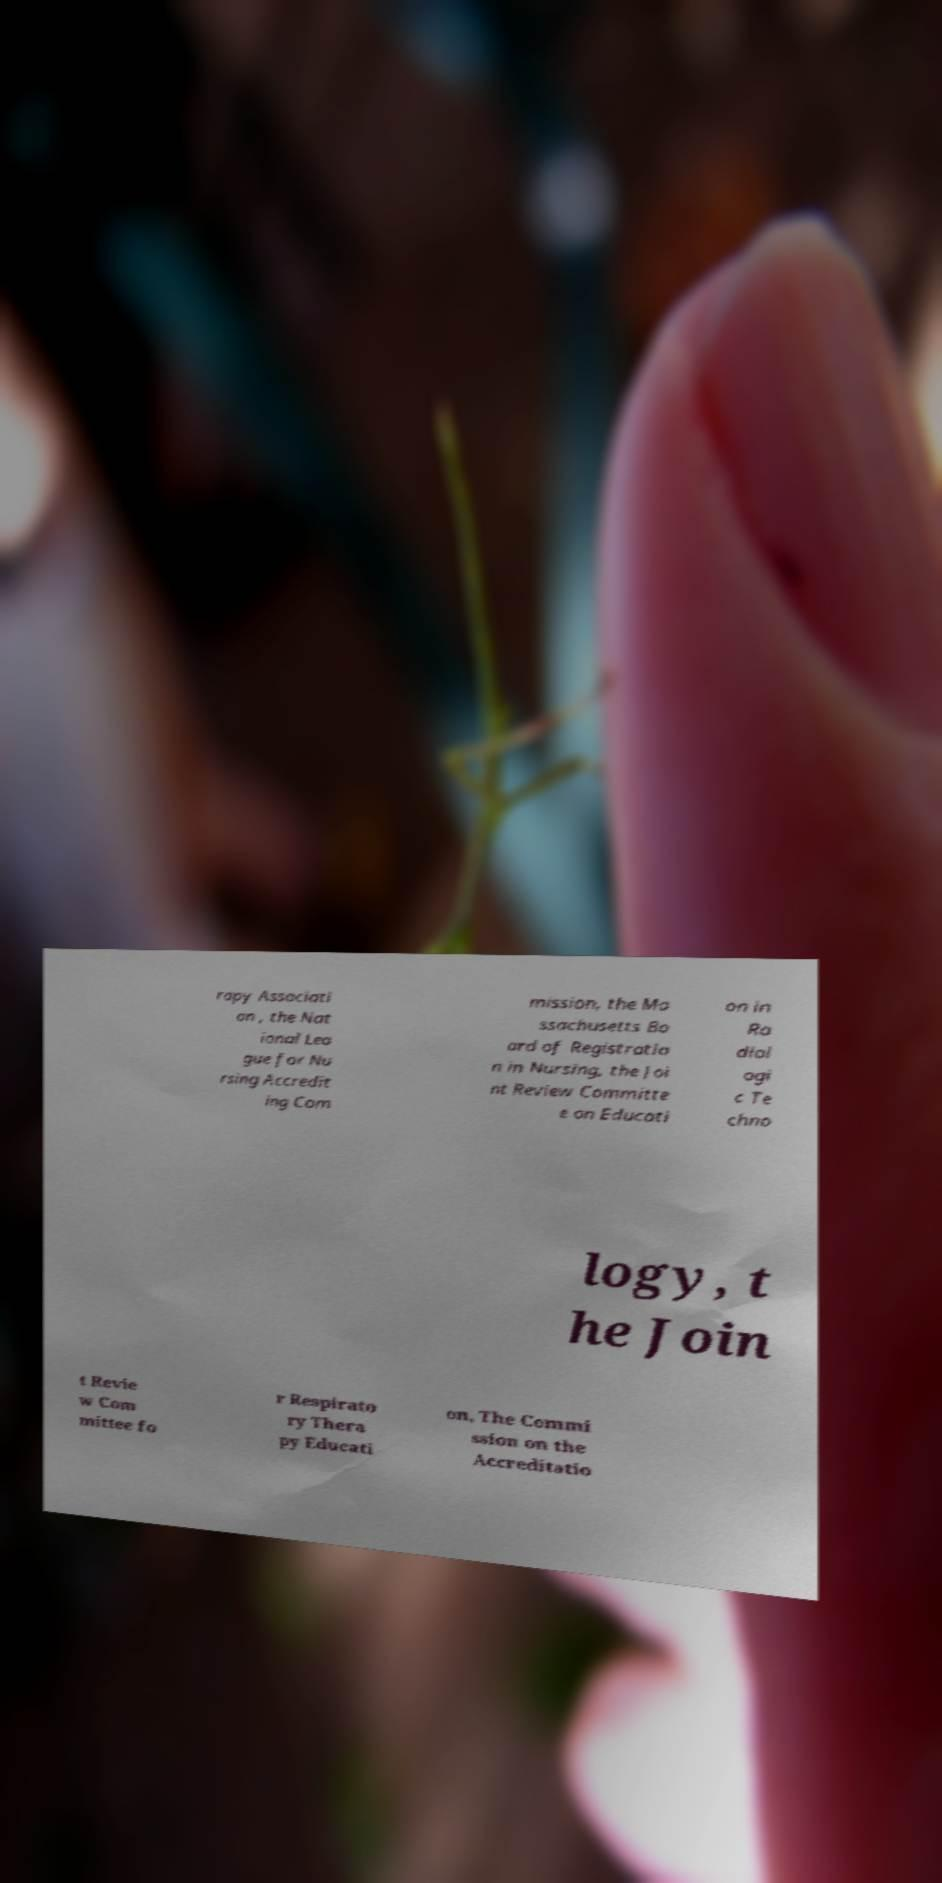For documentation purposes, I need the text within this image transcribed. Could you provide that? rapy Associati on , the Nat ional Lea gue for Nu rsing Accredit ing Com mission, the Ma ssachusetts Bo ard of Registratio n in Nursing, the Joi nt Review Committe e on Educati on in Ra diol ogi c Te chno logy, t he Join t Revie w Com mittee fo r Respirato ry Thera py Educati on, The Commi ssion on the Accreditatio 